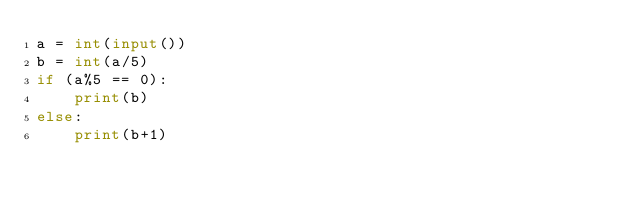<code> <loc_0><loc_0><loc_500><loc_500><_Python_>a = int(input())
b = int(a/5)
if (a%5 == 0):
    print(b)
else:
    print(b+1)
</code> 